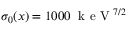<formula> <loc_0><loc_0><loc_500><loc_500>\sigma _ { 0 } ( x ) = 1 0 0 0 \, k e V ^ { 7 / 2 }</formula> 